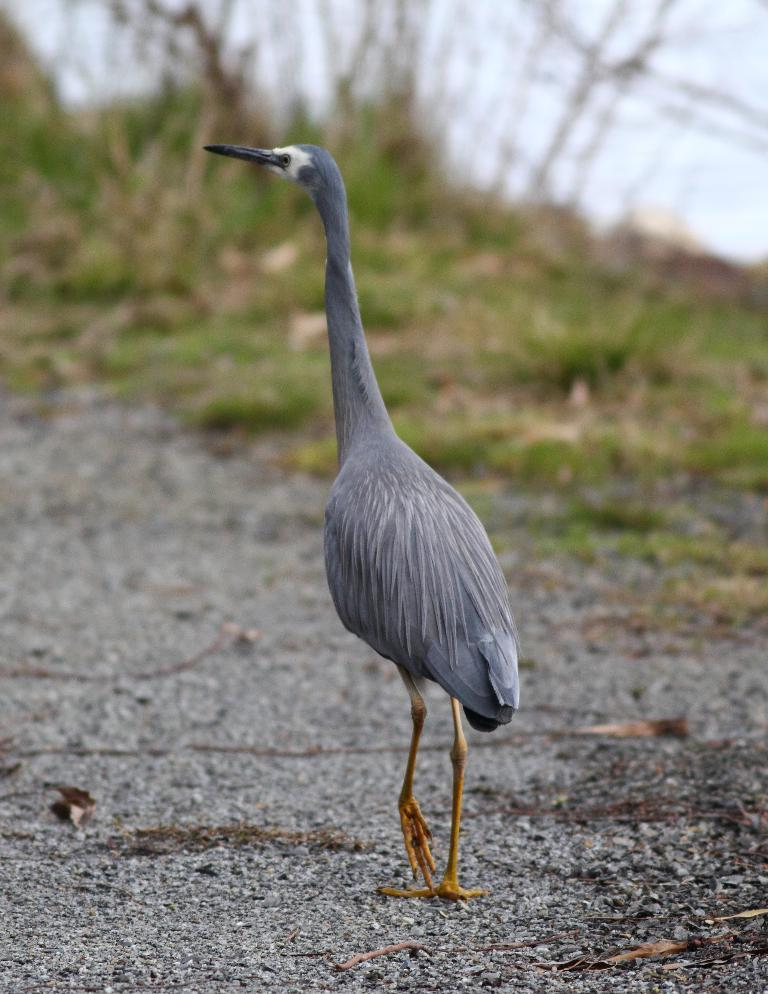What type of animal is in the image? There is a bird in the image. Where is the bird located? The bird is on the road. What color is the bird? The bird is grey in color. What type of vegetation can be seen in the image? There are plants visible in the image. What natural element is present in the image? There is water in the image. What type of ground cover is visible in the image? There is grass in the image. What man-made structure is present in the image? There is a road in the image. Who is offering a baby to the bird in the image? There is no baby or person offering a baby in the image; it only features a grey bird on the road. 